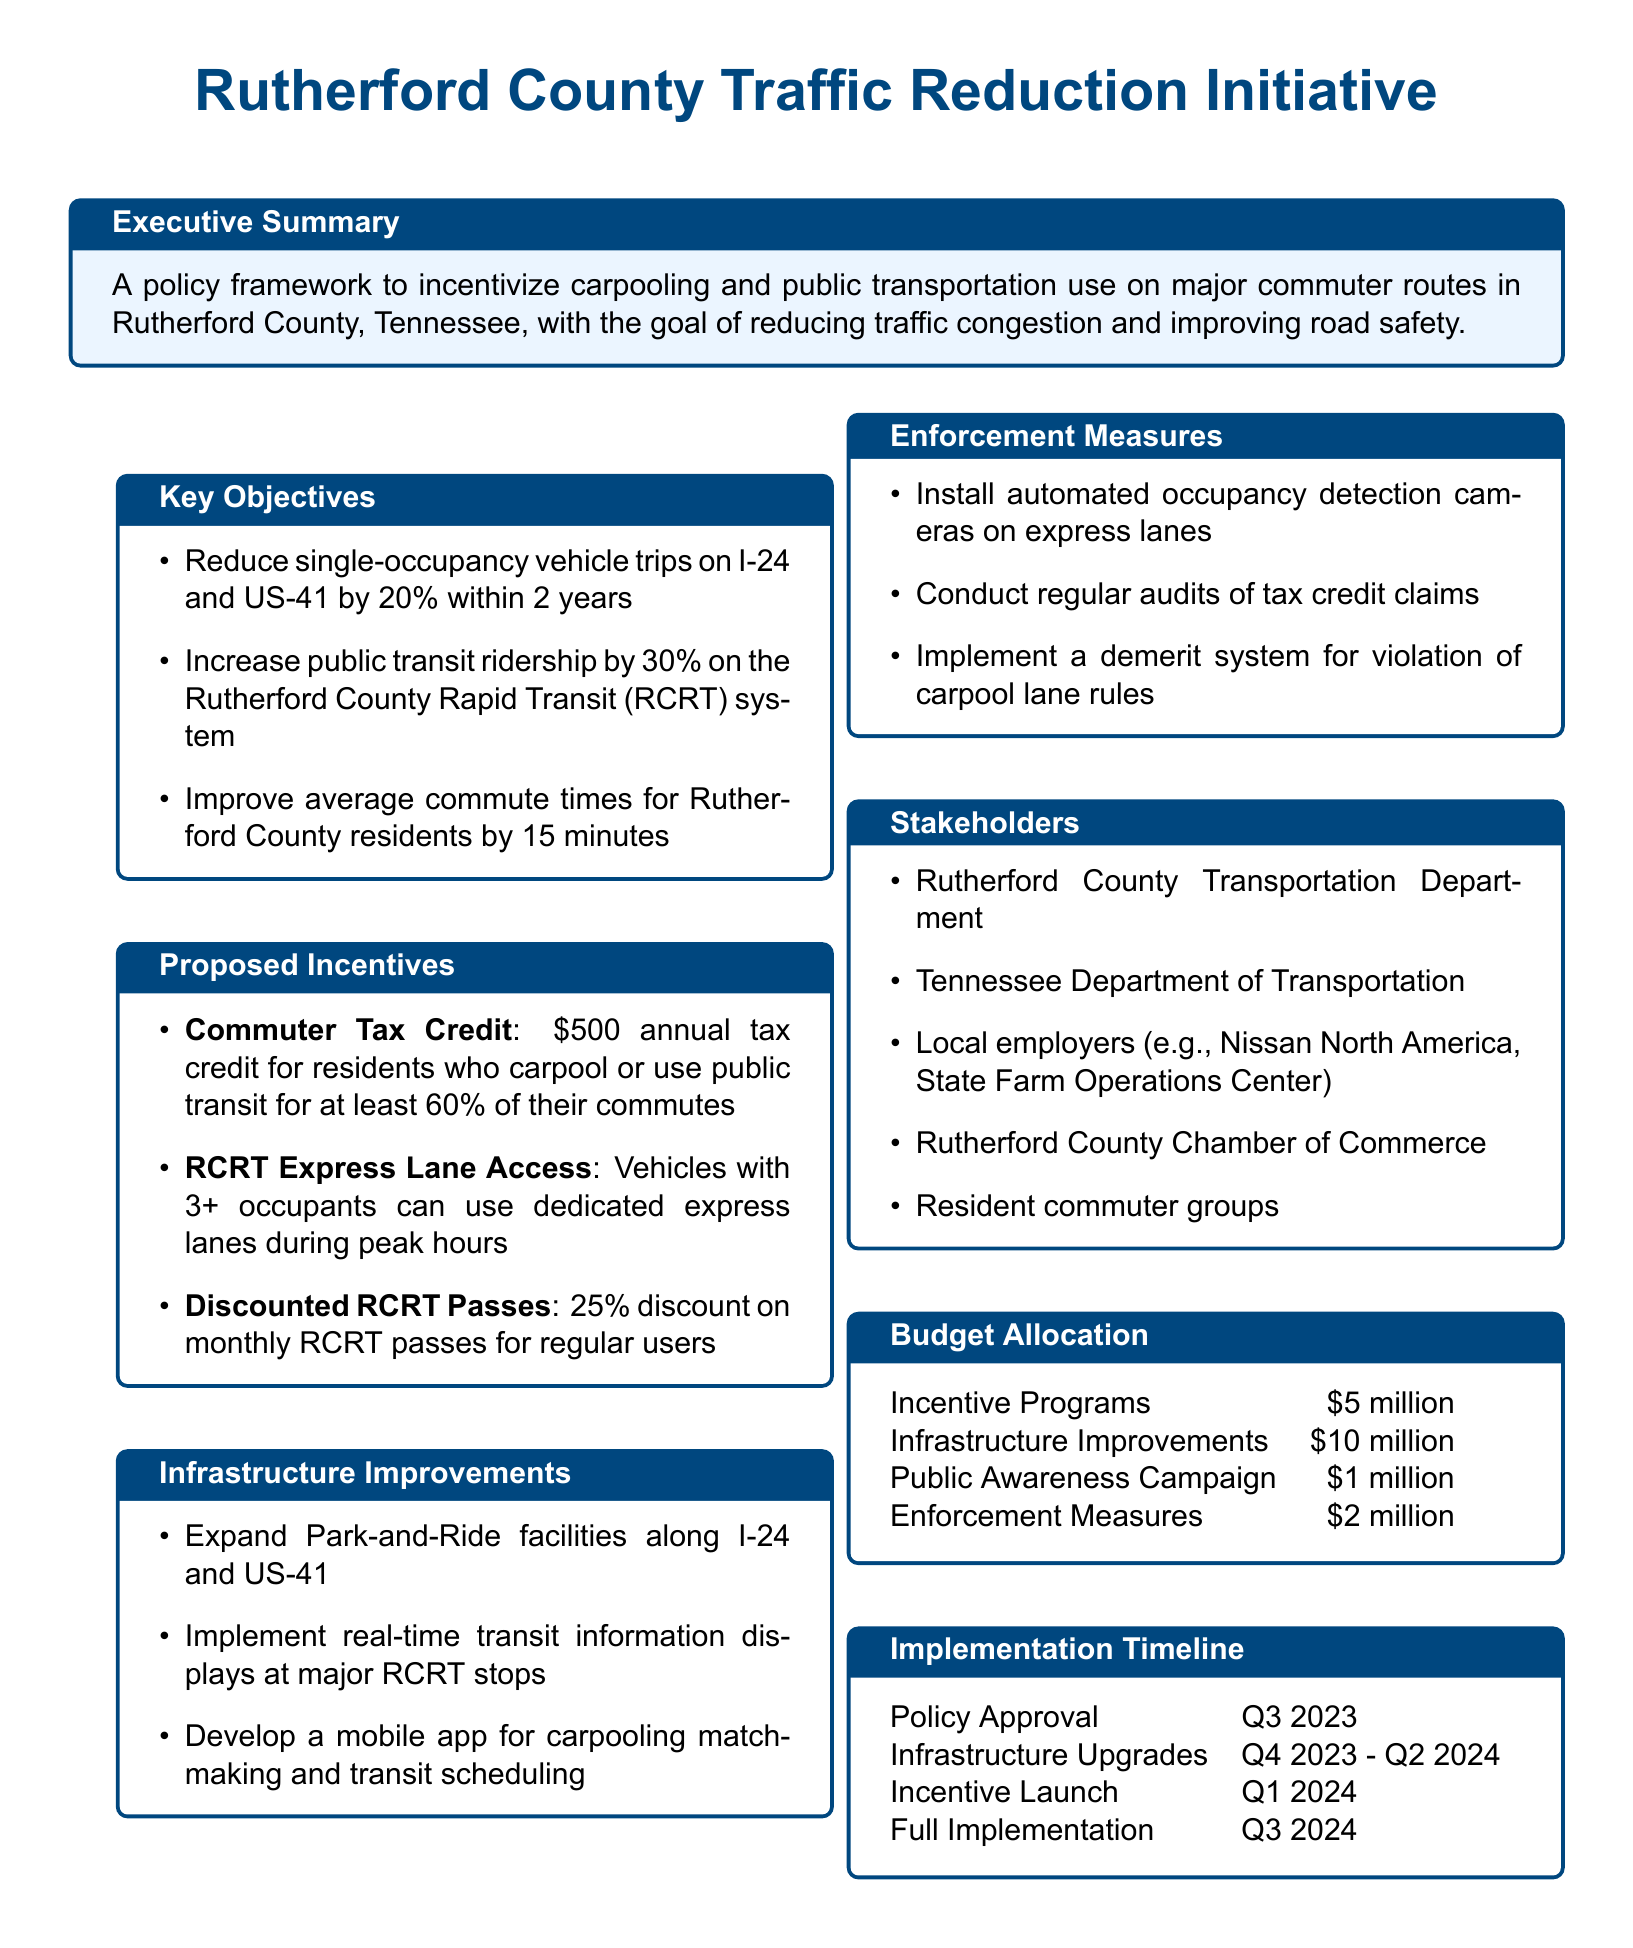what is the goal of the policy framework? The goal is to reduce traffic congestion and improve road safety.
Answer: reduce traffic congestion and improve road safety what percentage reduction in single-occupancy vehicle trips is targeted? The document states that the objective is to reduce single-occupancy vehicle trips by 20% within 2 years.
Answer: 20% how much discount is offered on monthly RCRT passes? The document mentions a 25% discount for regular users of the RCRT system.
Answer: 25% who are the local employers identified as stakeholders? The stakeholders include local employers like Nissan North America and State Farm Operations Center.
Answer: Nissan North America, State Farm Operations Center what is the budget allocated for infrastructure improvements? The document specifies that $10 million is allocated for infrastructure improvements.
Answer: $10 million in which quarter is the incentive launch planned? The timeline indicates that the incentive launch is planned for Q1 2024.
Answer: Q1 2024 what is the proposed commuter tax credit amount? The proposed commuter tax credit amount is $500 annually.
Answer: $500 how long is the full implementation expected to take? The full implementation is set for Q3 2024, indicating a time frame of about a year from the incentive launch.
Answer: 1 year 